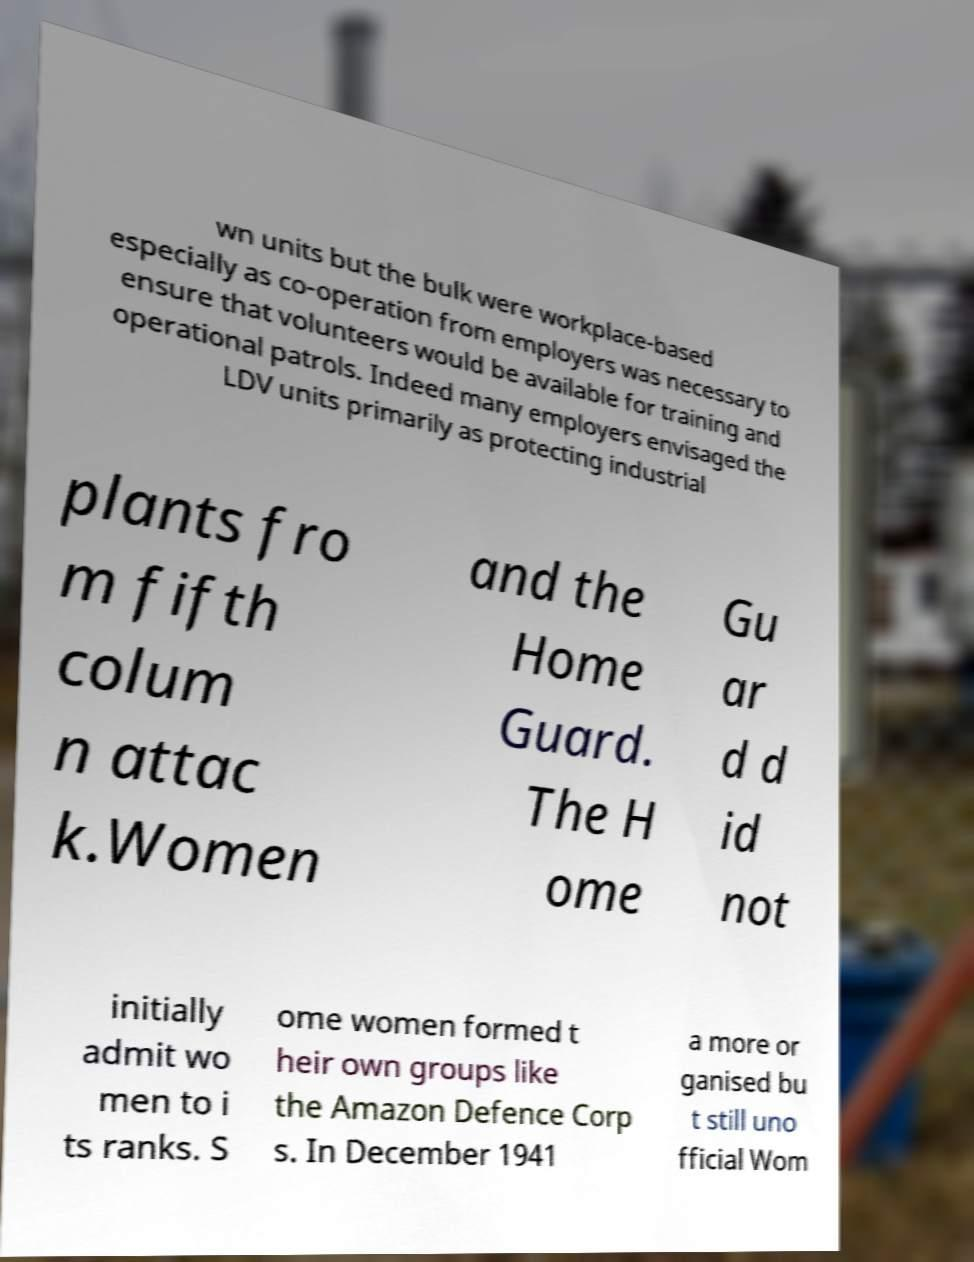What messages or text are displayed in this image? I need them in a readable, typed format. wn units but the bulk were workplace-based especially as co-operation from employers was necessary to ensure that volunteers would be available for training and operational patrols. Indeed many employers envisaged the LDV units primarily as protecting industrial plants fro m fifth colum n attac k.Women and the Home Guard. The H ome Gu ar d d id not initially admit wo men to i ts ranks. S ome women formed t heir own groups like the Amazon Defence Corp s. In December 1941 a more or ganised bu t still uno fficial Wom 